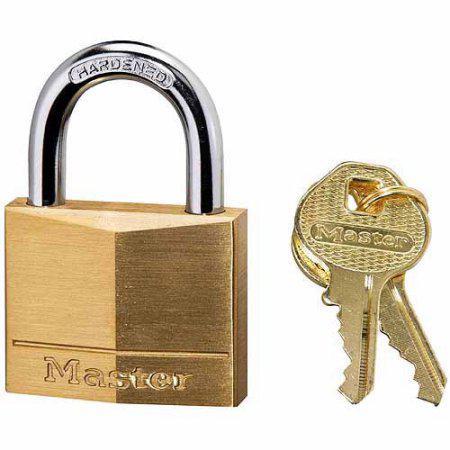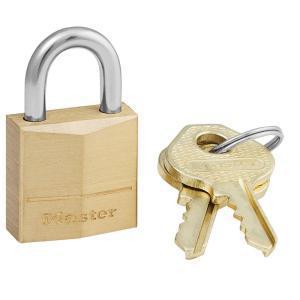The first image is the image on the left, the second image is the image on the right. Evaluate the accuracy of this statement regarding the images: "There is only one key.". Is it true? Answer yes or no. No. 